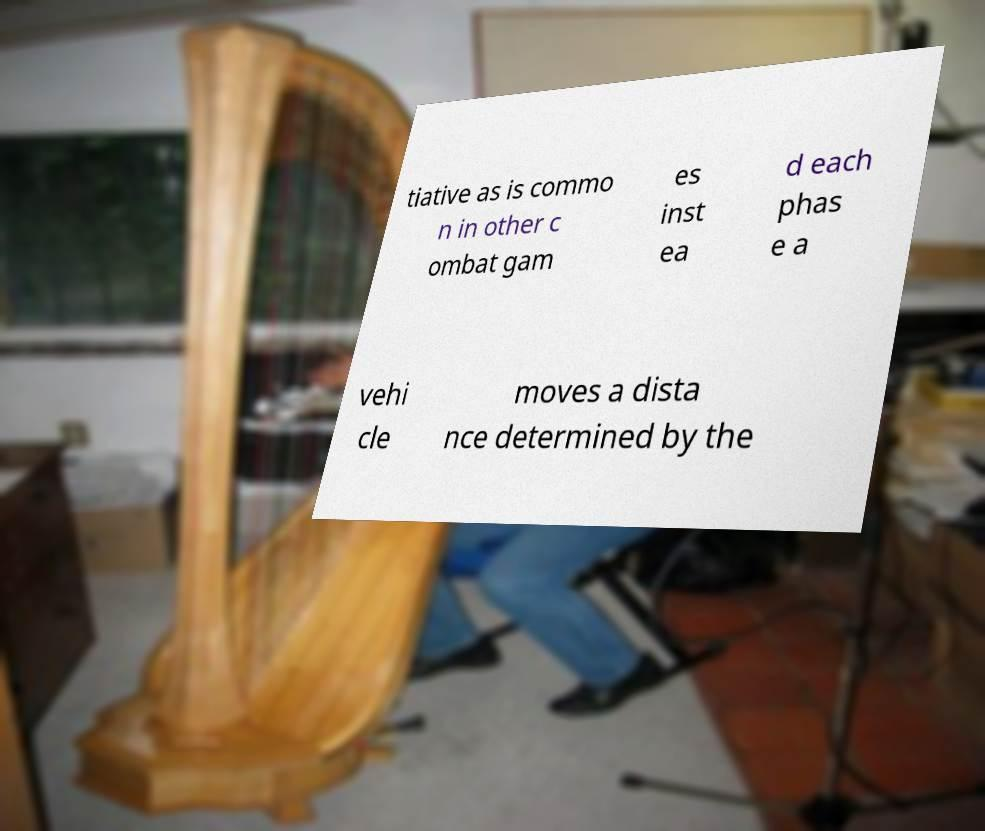Could you assist in decoding the text presented in this image and type it out clearly? tiative as is commo n in other c ombat gam es inst ea d each phas e a vehi cle moves a dista nce determined by the 